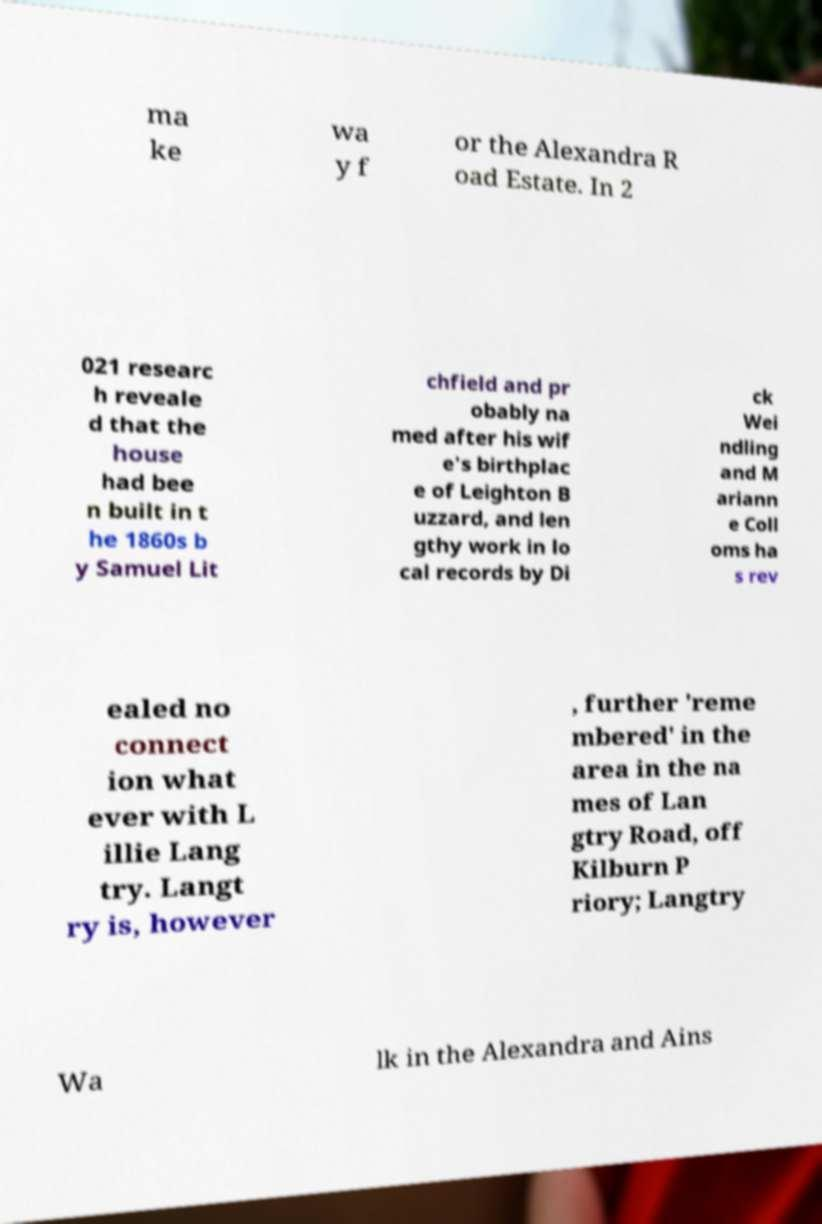What messages or text are displayed in this image? I need them in a readable, typed format. ma ke wa y f or the Alexandra R oad Estate. In 2 021 researc h reveale d that the house had bee n built in t he 1860s b y Samuel Lit chfield and pr obably na med after his wif e's birthplac e of Leighton B uzzard, and len gthy work in lo cal records by Di ck Wei ndling and M ariann e Coll oms ha s rev ealed no connect ion what ever with L illie Lang try. Langt ry is, however , further 'reme mbered' in the area in the na mes of Lan gtry Road, off Kilburn P riory; Langtry Wa lk in the Alexandra and Ains 